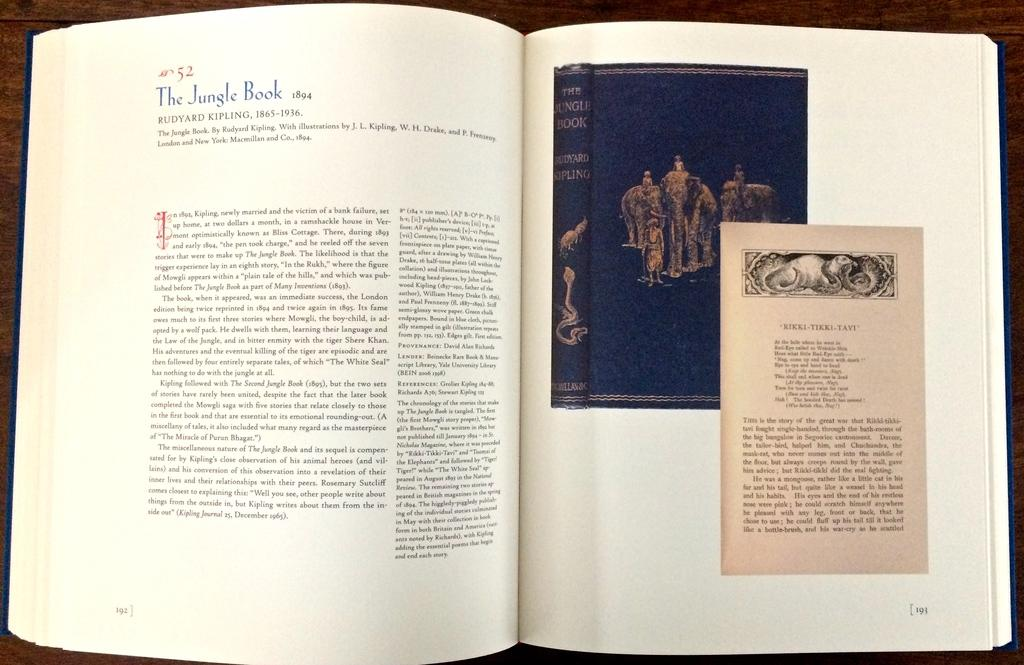<image>
Create a compact narrative representing the image presented. a large book is opened to a page that starts the Jungle Book story 